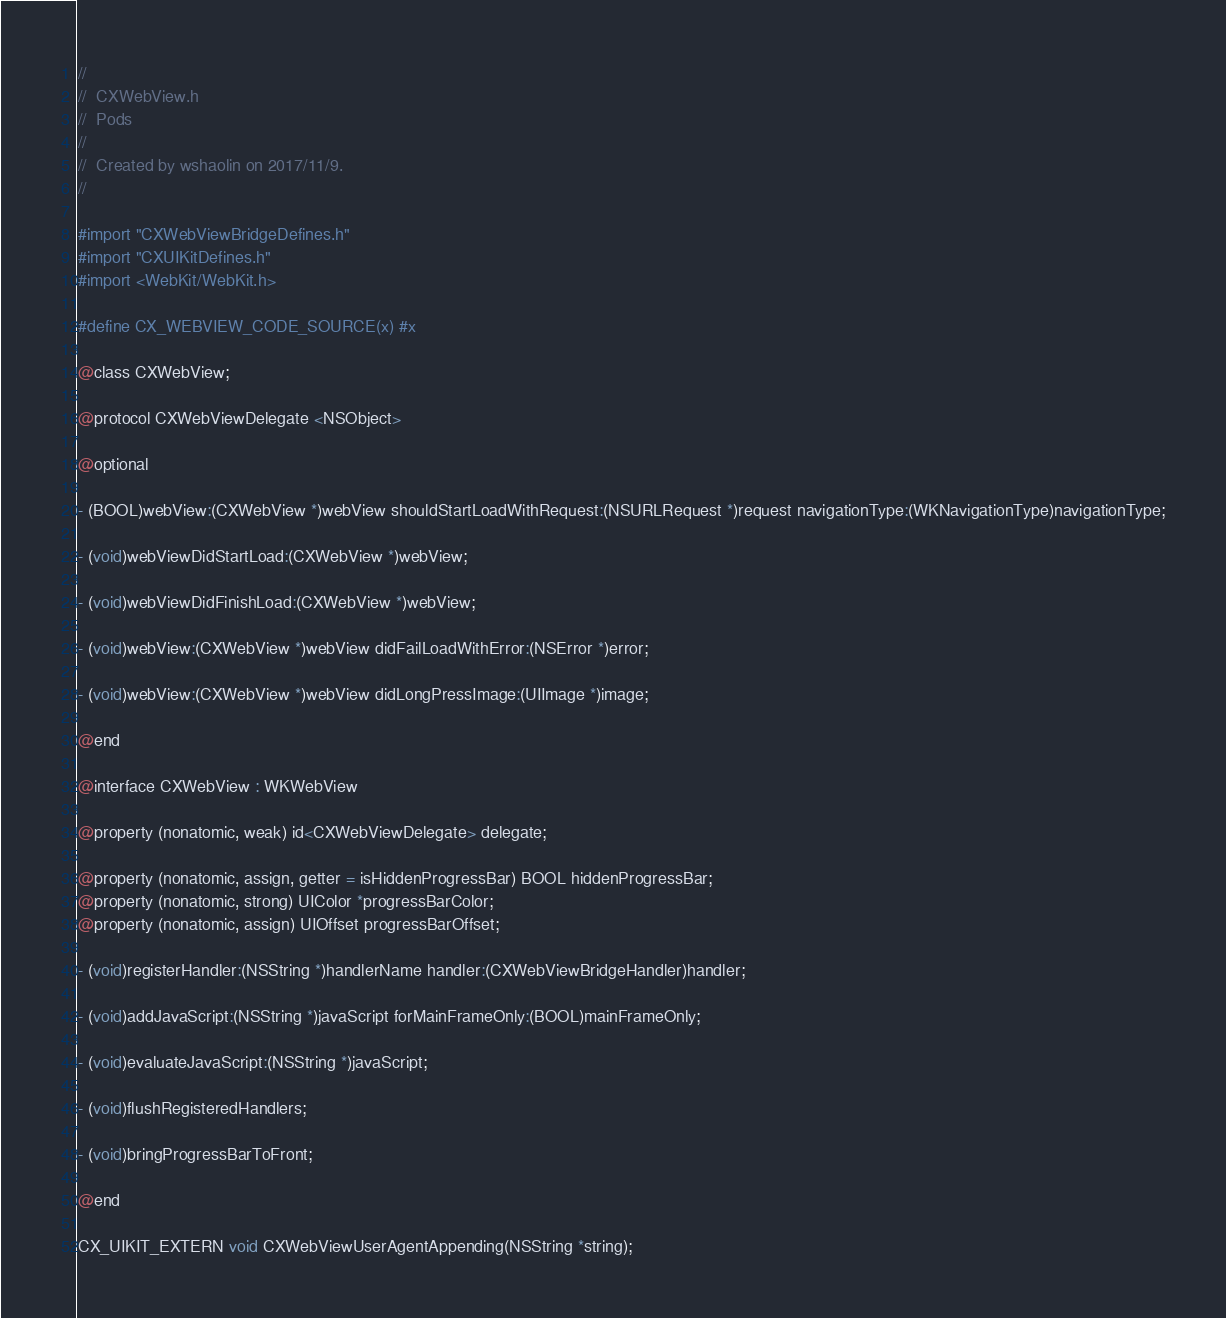<code> <loc_0><loc_0><loc_500><loc_500><_C_>//
//  CXWebView.h
//  Pods
//
//  Created by wshaolin on 2017/11/9.
//

#import "CXWebViewBridgeDefines.h"
#import "CXUIKitDefines.h"
#import <WebKit/WebKit.h>

#define CX_WEBVIEW_CODE_SOURCE(x) #x

@class CXWebView;

@protocol CXWebViewDelegate <NSObject>

@optional

- (BOOL)webView:(CXWebView *)webView shouldStartLoadWithRequest:(NSURLRequest *)request navigationType:(WKNavigationType)navigationType;

- (void)webViewDidStartLoad:(CXWebView *)webView;

- (void)webViewDidFinishLoad:(CXWebView *)webView;

- (void)webView:(CXWebView *)webView didFailLoadWithError:(NSError *)error;

- (void)webView:(CXWebView *)webView didLongPressImage:(UIImage *)image;

@end

@interface CXWebView : WKWebView

@property (nonatomic, weak) id<CXWebViewDelegate> delegate;

@property (nonatomic, assign, getter = isHiddenProgressBar) BOOL hiddenProgressBar;
@property (nonatomic, strong) UIColor *progressBarColor;
@property (nonatomic, assign) UIOffset progressBarOffset;

- (void)registerHandler:(NSString *)handlerName handler:(CXWebViewBridgeHandler)handler;

- (void)addJavaScript:(NSString *)javaScript forMainFrameOnly:(BOOL)mainFrameOnly;

- (void)evaluateJavaScript:(NSString *)javaScript;

- (void)flushRegisteredHandlers;

- (void)bringProgressBarToFront;

@end

CX_UIKIT_EXTERN void CXWebViewUserAgentAppending(NSString *string);
</code> 